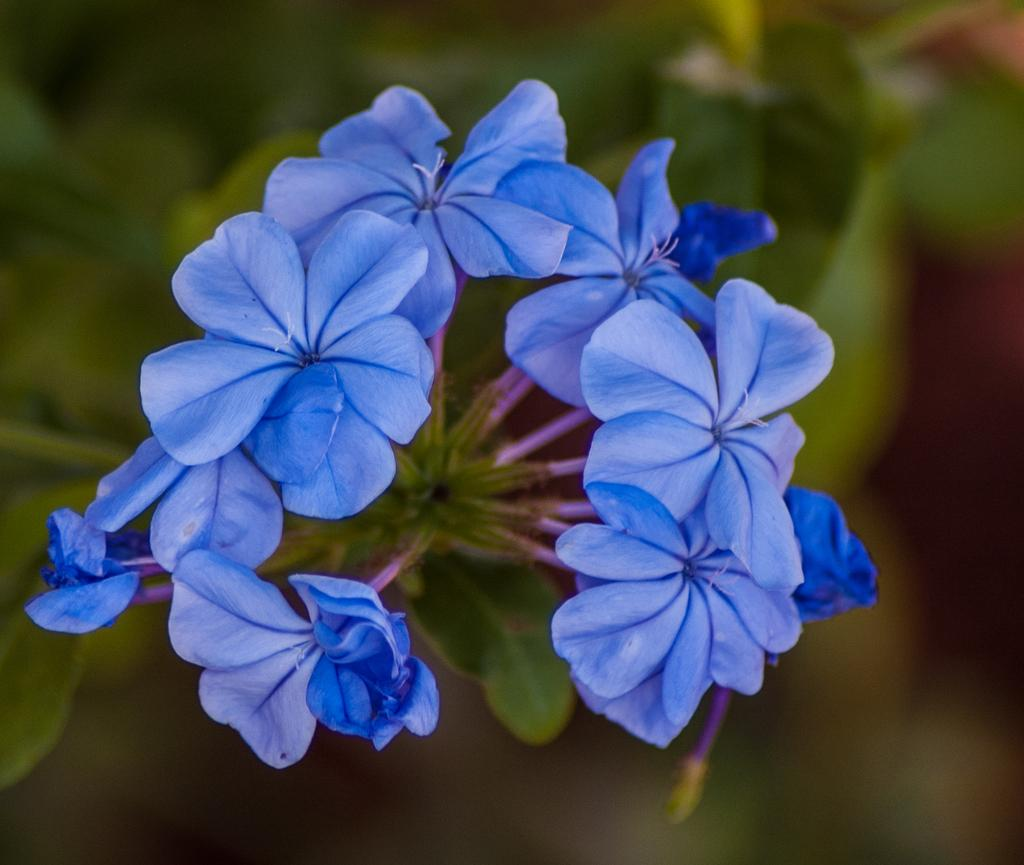What type of objects are present in the image? There are flowers in the image. Can you describe the color of the flowers? The flowers are blue in color. How would you describe the background of the image? The background of the image is blurred. How many pizzas are on the plate in the image? There are no pizzas or plates present in the image; it features blue flowers with a blurred background. What type of suit is the person wearing in the image? There is no person or suit present in the image; it features blue flowers with a blurred background. 